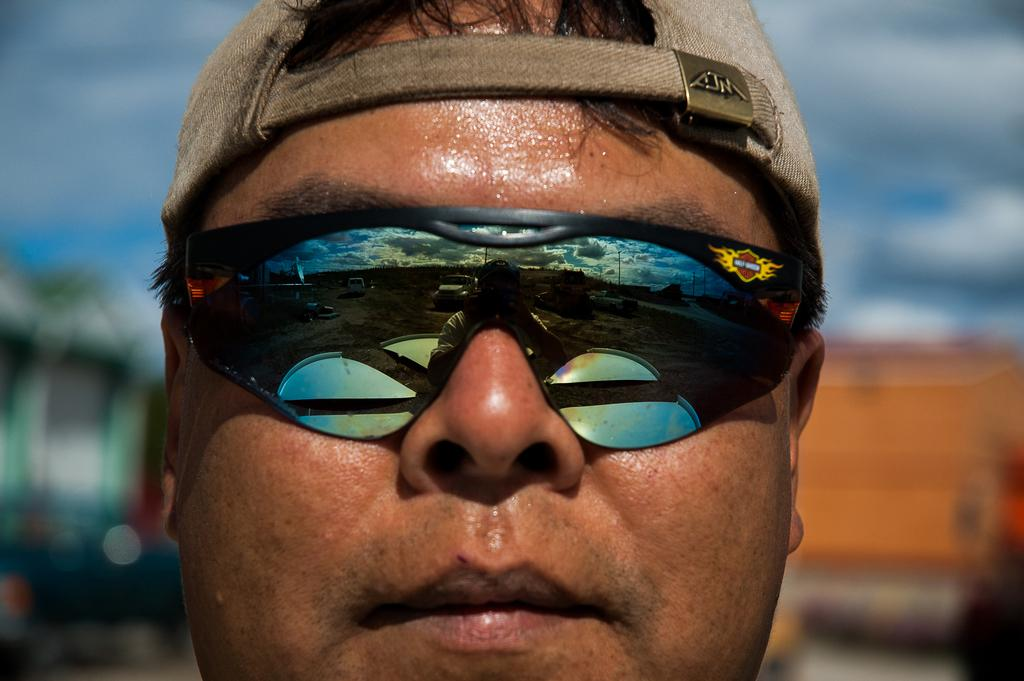What type of accessory is present in the image? There is a cap in the image. Who is visible in the image? The face of a man is visible in the image. What can be seen in the goggles in the image? The reflection of vehicles on the ground can be seen in the goggles in the image. What are the tall, slender structures in the image? There are poles in the image. What is visible in the sky in the image? The sky with clouds is visible in the image. How would you describe the background of the image? The background of the image is blurry. What type of fang can be seen in the image? There is no fang present in the image. Is the man wearing a ring in the image? The provided facts do not mention a ring, so we cannot determine if the man is wearing one. How does the man's temper affect the image? The man's temper is not mentioned in the provided facts, so we cannot determine its effect on the image. 